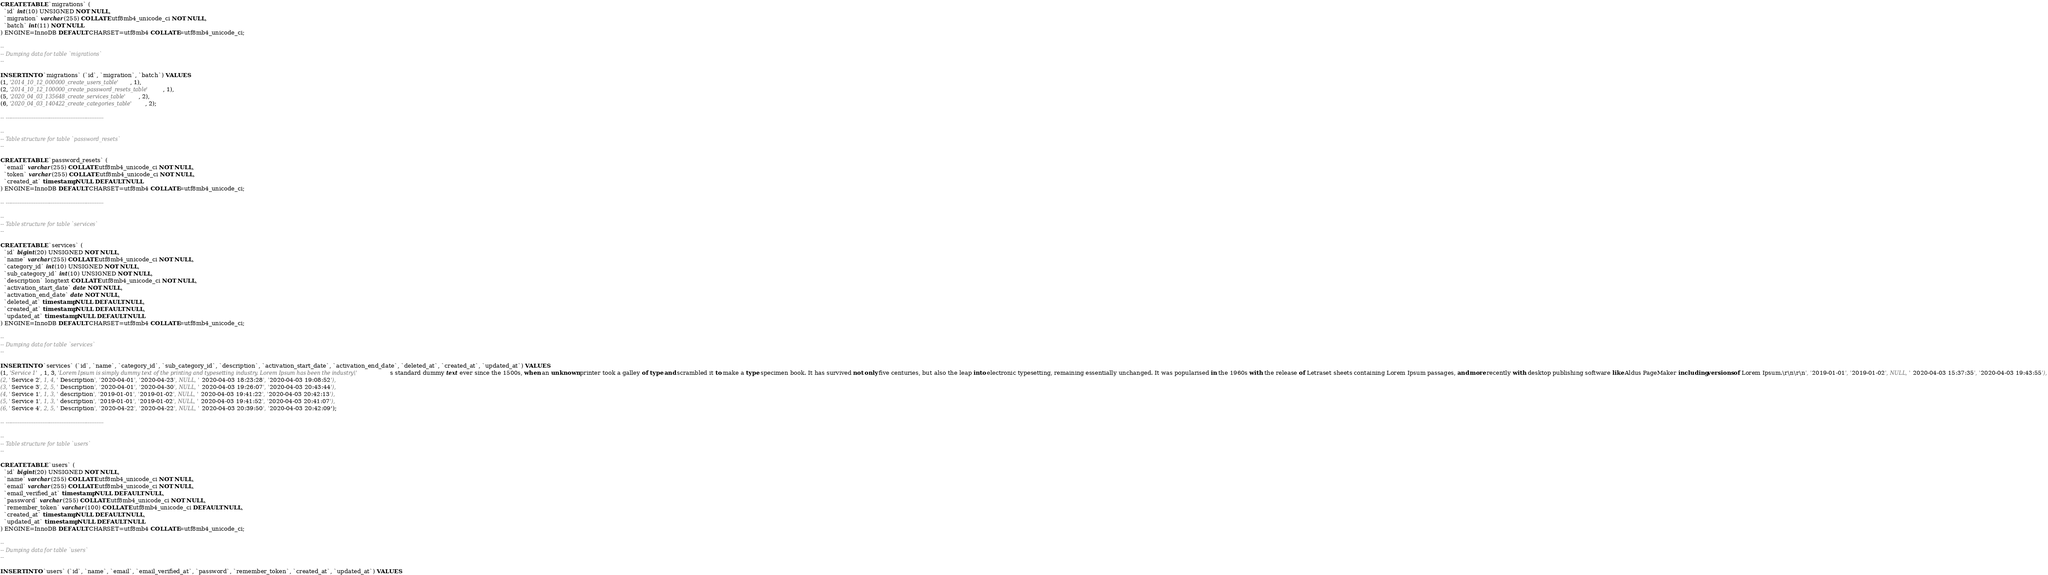Convert code to text. <code><loc_0><loc_0><loc_500><loc_500><_SQL_>CREATE TABLE `migrations` (
  `id` int(10) UNSIGNED NOT NULL,
  `migration` varchar(255) COLLATE utf8mb4_unicode_ci NOT NULL,
  `batch` int(11) NOT NULL
) ENGINE=InnoDB DEFAULT CHARSET=utf8mb4 COLLATE=utf8mb4_unicode_ci;

--
-- Dumping data for table `migrations`
--

INSERT INTO `migrations` (`id`, `migration`, `batch`) VALUES
(1, '2014_10_12_000000_create_users_table', 1),
(2, '2014_10_12_100000_create_password_resets_table', 1),
(5, '2020_04_03_135648_create_services_table', 2),
(6, '2020_04_03_140422_create_categories_table', 2);

-- --------------------------------------------------------

--
-- Table structure for table `password_resets`
--

CREATE TABLE `password_resets` (
  `email` varchar(255) COLLATE utf8mb4_unicode_ci NOT NULL,
  `token` varchar(255) COLLATE utf8mb4_unicode_ci NOT NULL,
  `created_at` timestamp NULL DEFAULT NULL
) ENGINE=InnoDB DEFAULT CHARSET=utf8mb4 COLLATE=utf8mb4_unicode_ci;

-- --------------------------------------------------------

--
-- Table structure for table `services`
--

CREATE TABLE `services` (
  `id` bigint(20) UNSIGNED NOT NULL,
  `name` varchar(255) COLLATE utf8mb4_unicode_ci NOT NULL,
  `category_id` int(10) UNSIGNED NOT NULL,
  `sub_category_id` int(10) UNSIGNED NOT NULL,
  `description` longtext COLLATE utf8mb4_unicode_ci NOT NULL,
  `activation_start_date` date NOT NULL,
  `activation_end_date` date NOT NULL,
  `deleted_at` timestamp NULL DEFAULT NULL,
  `created_at` timestamp NULL DEFAULT NULL,
  `updated_at` timestamp NULL DEFAULT NULL
) ENGINE=InnoDB DEFAULT CHARSET=utf8mb4 COLLATE=utf8mb4_unicode_ci;

--
-- Dumping data for table `services`
--

INSERT INTO `services` (`id`, `name`, `category_id`, `sub_category_id`, `description`, `activation_start_date`, `activation_end_date`, `deleted_at`, `created_at`, `updated_at`) VALUES
(1, 'Service 1', 1, 3, 'Lorem Ipsum is simply dummy text of the printing and typesetting industry. Lorem Ipsum has been the industry\'s standard dummy text ever since the 1500s, when an unknown printer took a galley of type and scrambled it to make a type specimen book. It has survived not only five centuries, but also the leap into electronic typesetting, remaining essentially unchanged. It was popularised in the 1960s with the release of Letraset sheets containing Lorem Ipsum passages, and more recently with desktop publishing software like Aldus PageMaker including versions of Lorem Ipsum.\r\n\r\n', '2019-01-01', '2019-01-02', NULL, '2020-04-03 15:37:35', '2020-04-03 19:43:55'),
(2, 'Service 2', 1, 4, 'Description', '2020-04-01', '2020-04-23', NULL, '2020-04-03 18:23:28', '2020-04-03 19:08:52'),
(3, 'Service 3', 2, 5, 'Description', '2020-04-01', '2020-04-30', NULL, '2020-04-03 19:26:07', '2020-04-03 20:43:44'),
(4, 'Service 1', 1, 3, 'description', '2019-01-01', '2019-01-02', NULL, '2020-04-03 19:41:22', '2020-04-03 20:42:13'),
(5, 'Service 1', 1, 3, 'description', '2019-01-01', '2019-01-02', NULL, '2020-04-03 19:41:52', '2020-04-03 20:41:07'),
(6, 'Service 4', 2, 5, 'Description', '2020-04-22', '2020-04-22', NULL, '2020-04-03 20:39:50', '2020-04-03 20:42:09');

-- --------------------------------------------------------

--
-- Table structure for table `users`
--

CREATE TABLE `users` (
  `id` bigint(20) UNSIGNED NOT NULL,
  `name` varchar(255) COLLATE utf8mb4_unicode_ci NOT NULL,
  `email` varchar(255) COLLATE utf8mb4_unicode_ci NOT NULL,
  `email_verified_at` timestamp NULL DEFAULT NULL,
  `password` varchar(255) COLLATE utf8mb4_unicode_ci NOT NULL,
  `remember_token` varchar(100) COLLATE utf8mb4_unicode_ci DEFAULT NULL,
  `created_at` timestamp NULL DEFAULT NULL,
  `updated_at` timestamp NULL DEFAULT NULL
) ENGINE=InnoDB DEFAULT CHARSET=utf8mb4 COLLATE=utf8mb4_unicode_ci;

--
-- Dumping data for table `users`
--

INSERT INTO `users` (`id`, `name`, `email`, `email_verified_at`, `password`, `remember_token`, `created_at`, `updated_at`) VALUES</code> 